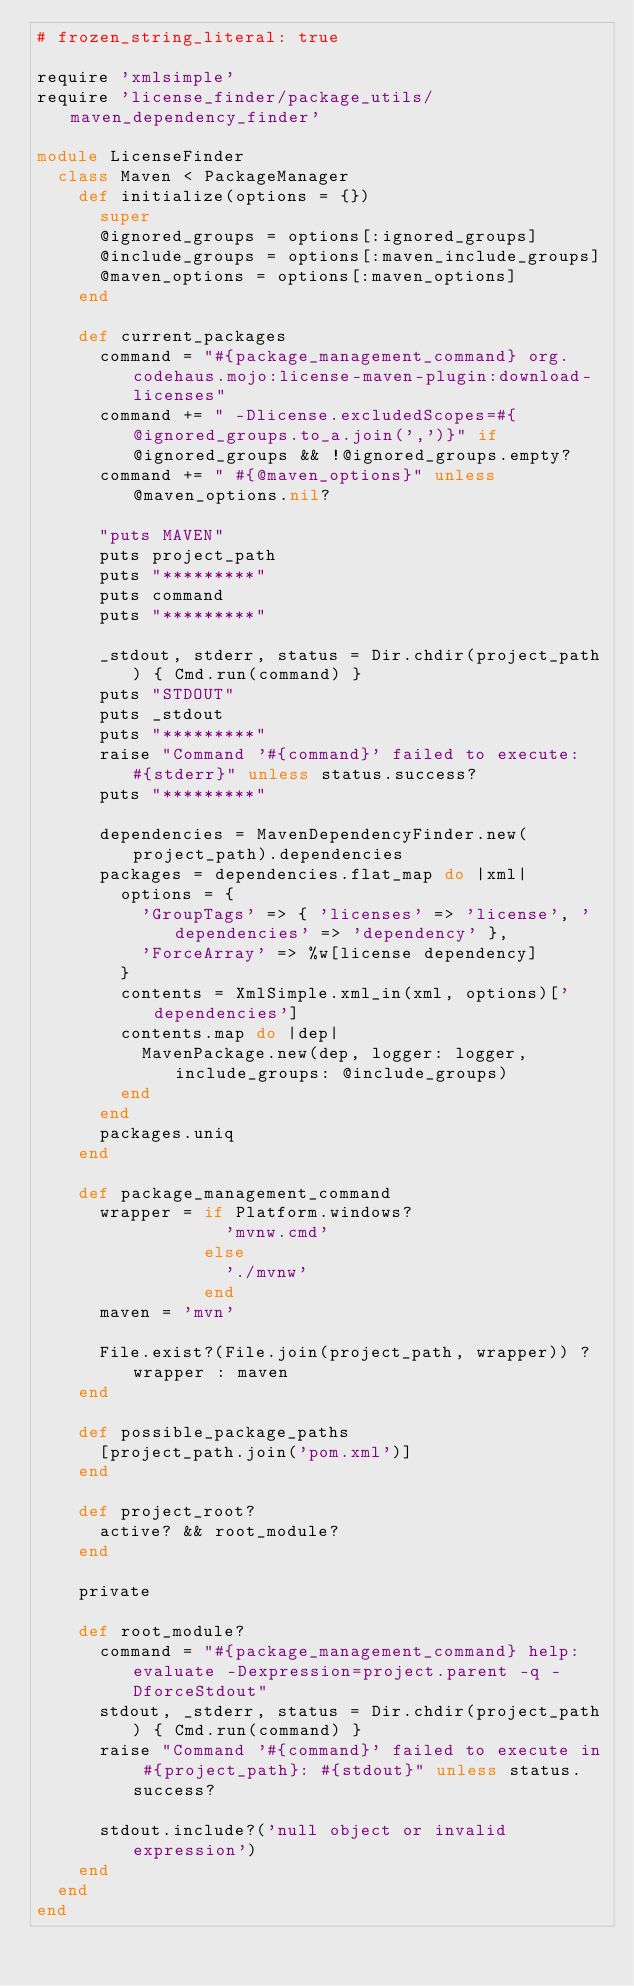<code> <loc_0><loc_0><loc_500><loc_500><_Ruby_># frozen_string_literal: true

require 'xmlsimple'
require 'license_finder/package_utils/maven_dependency_finder'

module LicenseFinder
  class Maven < PackageManager
    def initialize(options = {})
      super
      @ignored_groups = options[:ignored_groups]
      @include_groups = options[:maven_include_groups]
      @maven_options = options[:maven_options]
    end

    def current_packages
      command = "#{package_management_command} org.codehaus.mojo:license-maven-plugin:download-licenses"
      command += " -Dlicense.excludedScopes=#{@ignored_groups.to_a.join(',')}" if @ignored_groups && !@ignored_groups.empty?
      command += " #{@maven_options}" unless @maven_options.nil?
      
      "puts MAVEN"
      puts project_path
      puts "*********"
      puts command
      puts "*********"
      
      _stdout, stderr, status = Dir.chdir(project_path) { Cmd.run(command) }
      puts "STDOUT"
      puts _stdout
      puts "*********"
      raise "Command '#{command}' failed to execute: #{stderr}" unless status.success?
      puts "*********"

      dependencies = MavenDependencyFinder.new(project_path).dependencies
      packages = dependencies.flat_map do |xml|
        options = {
          'GroupTags' => { 'licenses' => 'license', 'dependencies' => 'dependency' },
          'ForceArray' => %w[license dependency]
        }
        contents = XmlSimple.xml_in(xml, options)['dependencies']
        contents.map do |dep|
          MavenPackage.new(dep, logger: logger, include_groups: @include_groups)
        end
      end
      packages.uniq
    end

    def package_management_command
      wrapper = if Platform.windows?
                  'mvnw.cmd'
                else
                  './mvnw'
                end
      maven = 'mvn'

      File.exist?(File.join(project_path, wrapper)) ? wrapper : maven
    end

    def possible_package_paths
      [project_path.join('pom.xml')]
    end

    def project_root?
      active? && root_module?
    end

    private

    def root_module?
      command = "#{package_management_command} help:evaluate -Dexpression=project.parent -q -DforceStdout"
      stdout, _stderr, status = Dir.chdir(project_path) { Cmd.run(command) }
      raise "Command '#{command}' failed to execute in #{project_path}: #{stdout}" unless status.success?

      stdout.include?('null object or invalid expression')
    end
  end
end
</code> 